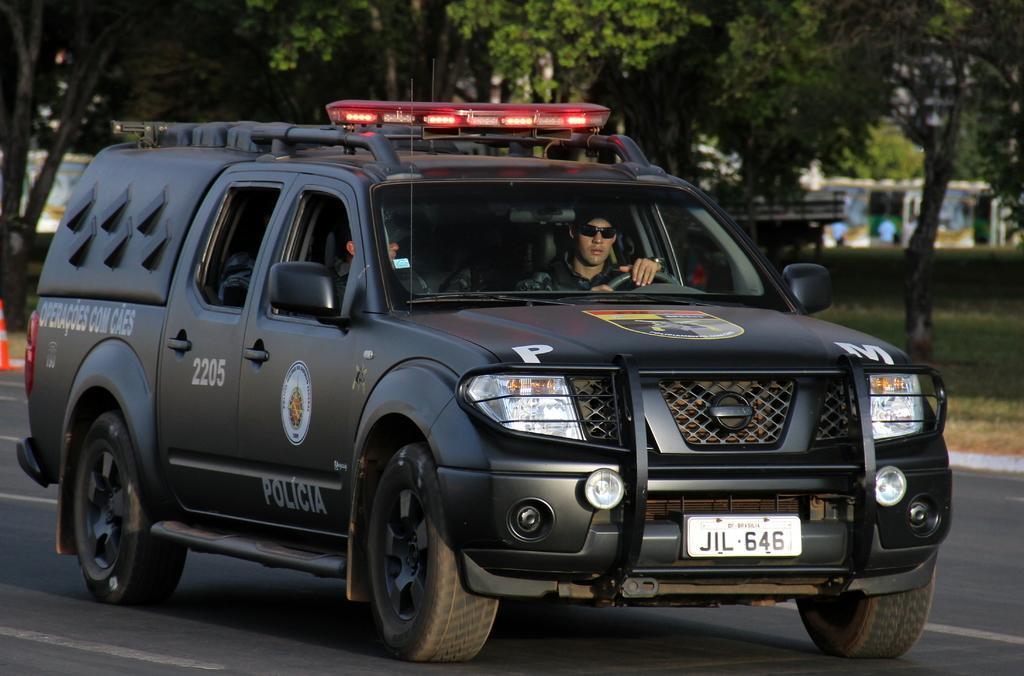Can you describe this image briefly? This image consists of a car in black color. It is a police vehicle. In which there are two persons. At the bottom, there is road. In the background, there are trees. 